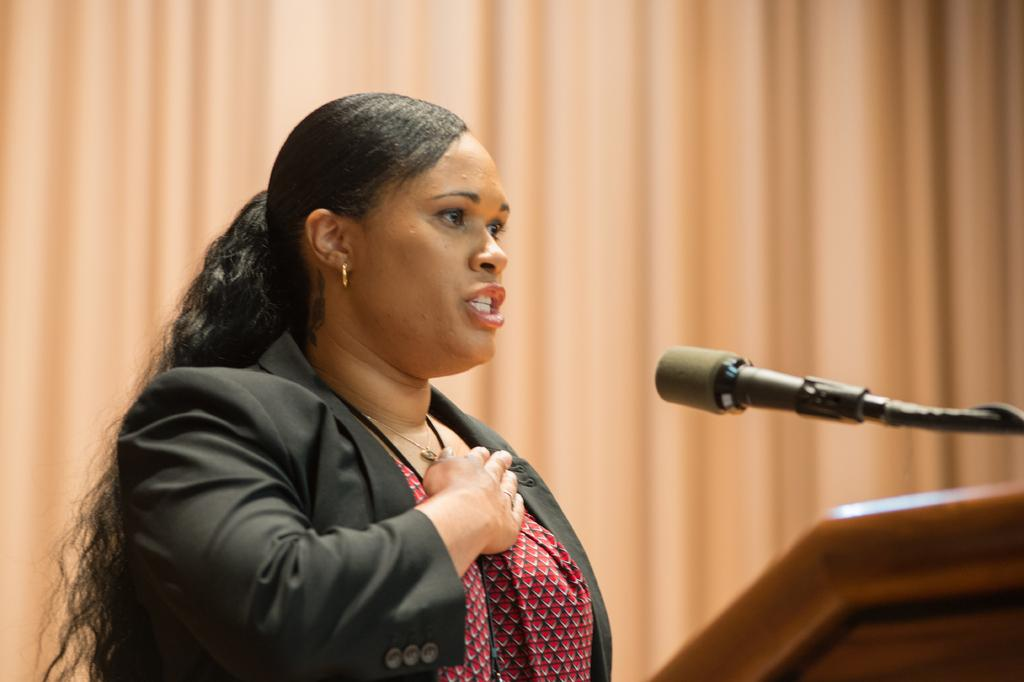Who is the main subject in the image? There is a woman in the image. What is the woman doing in the image? The woman is standing in front of a microphone. What other object is present in the image? There is a podium in the image. Can you describe the podium? The podium appears to be truncated. What can be seen in the background of the image? There is a curtain in the background of the image. How does the quilt contribute to the woman's speech in the image? There is no quilt present in the image, so it cannot contribute to the woman's speech. 